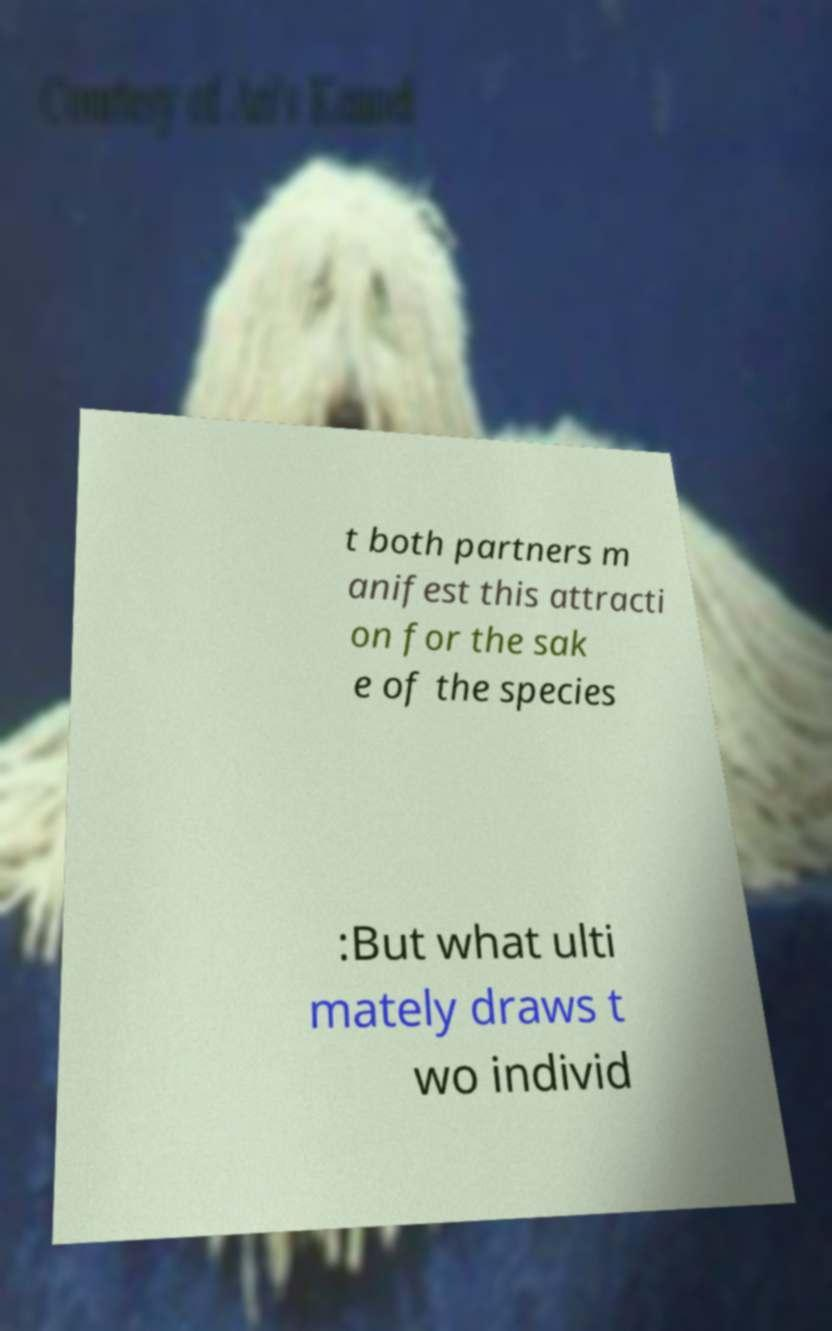Please identify and transcribe the text found in this image. t both partners m anifest this attracti on for the sak e of the species :But what ulti mately draws t wo individ 